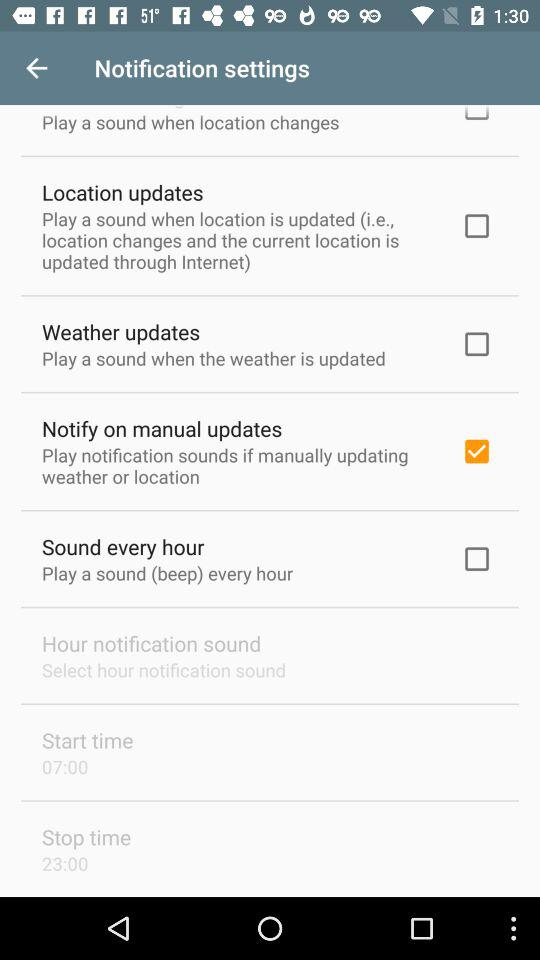What is the mentioned "Start time"? The mentioned "Start time" is 07:00. 